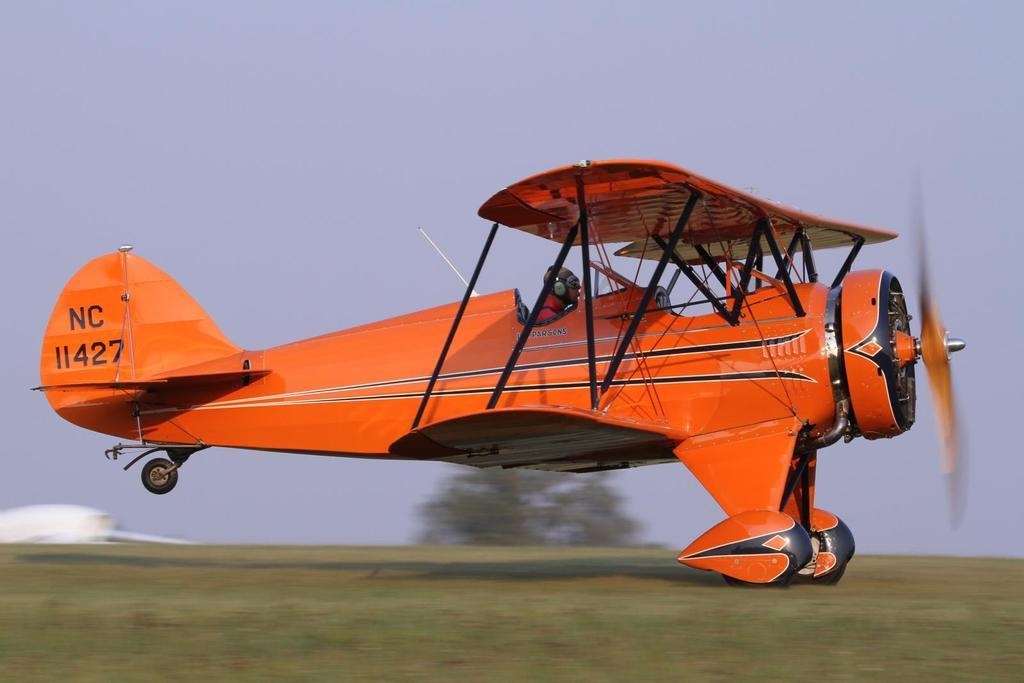<image>
Offer a succinct explanation of the picture presented. A small crop dusting plane is moving on the ground and has the call numbers NC11427. 